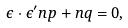<formula> <loc_0><loc_0><loc_500><loc_500>\epsilon \cdot \epsilon ^ { \prime } { n p } + { n q } = 0 ,</formula> 